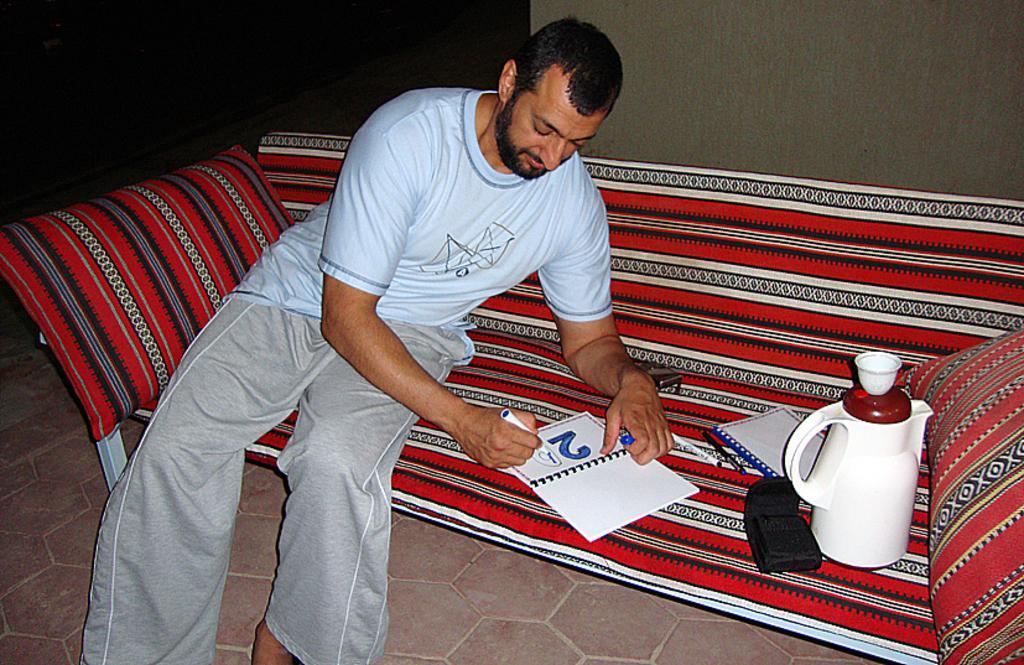Please provide a concise description of this image. The man in blue T-shirt is sitting on the red sofa. Behind him, we see a red pillow. He is holding the marker in his hand and he is writing something in the book. Beside him, we see two pens, a book and a flask. Beside that, we see a pillow. Behind him, we see a white wall. In the background, it is black in color. This picture is clicked inside the room. 